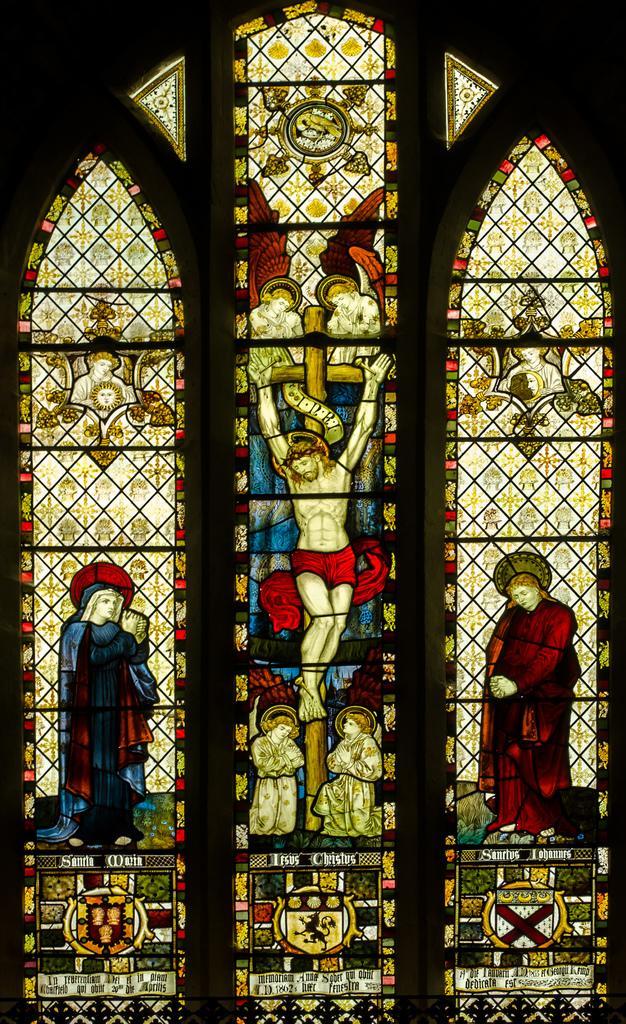In one or two sentences, can you explain what this image depicts? In this image, we can see the windows and some painting on it and in the background we can see the dark. 